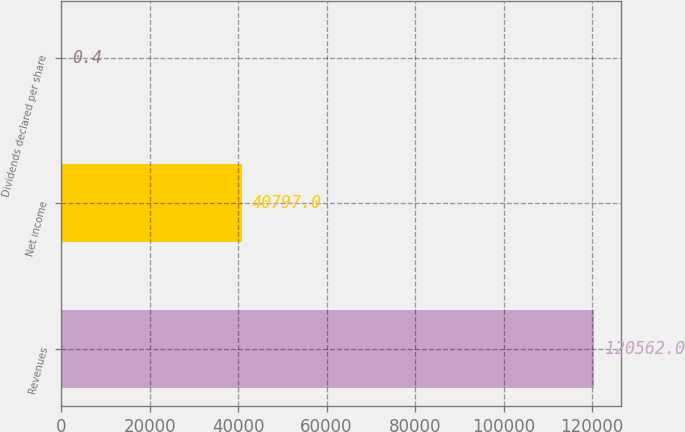Convert chart to OTSL. <chart><loc_0><loc_0><loc_500><loc_500><bar_chart><fcel>Revenues<fcel>Net income<fcel>Dividends declared per share<nl><fcel>120562<fcel>40797<fcel>0.4<nl></chart> 